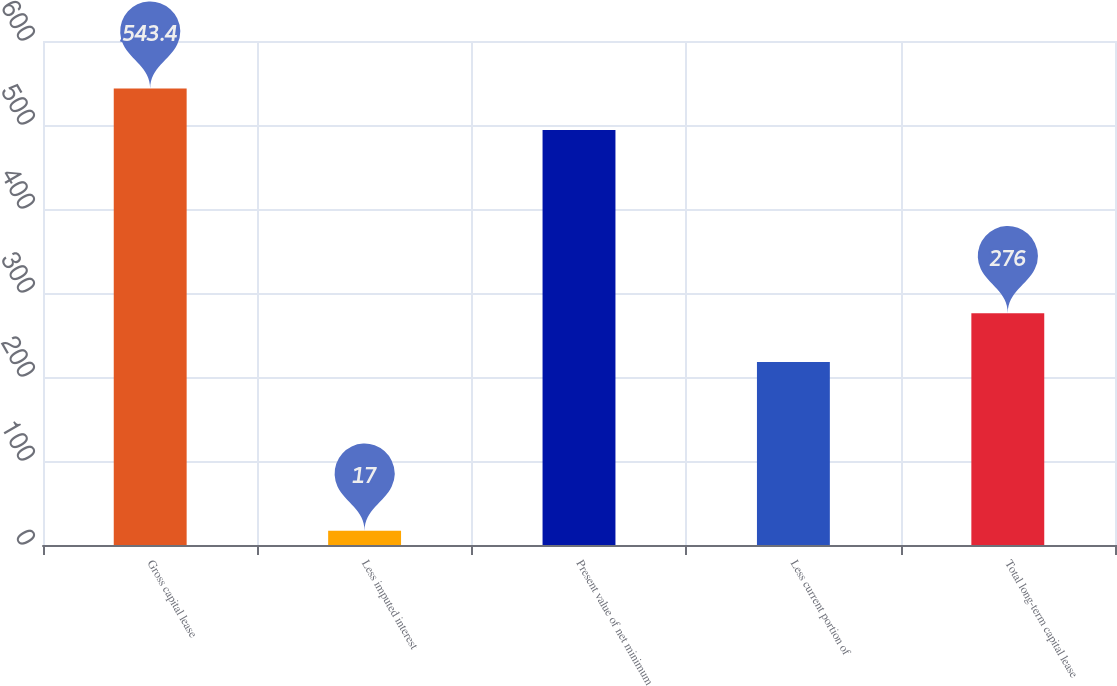Convert chart. <chart><loc_0><loc_0><loc_500><loc_500><bar_chart><fcel>Gross capital lease<fcel>Less imputed interest<fcel>Present value of net minimum<fcel>Less current portion of<fcel>Total long-term capital lease<nl><fcel>543.4<fcel>17<fcel>494<fcel>218<fcel>276<nl></chart> 